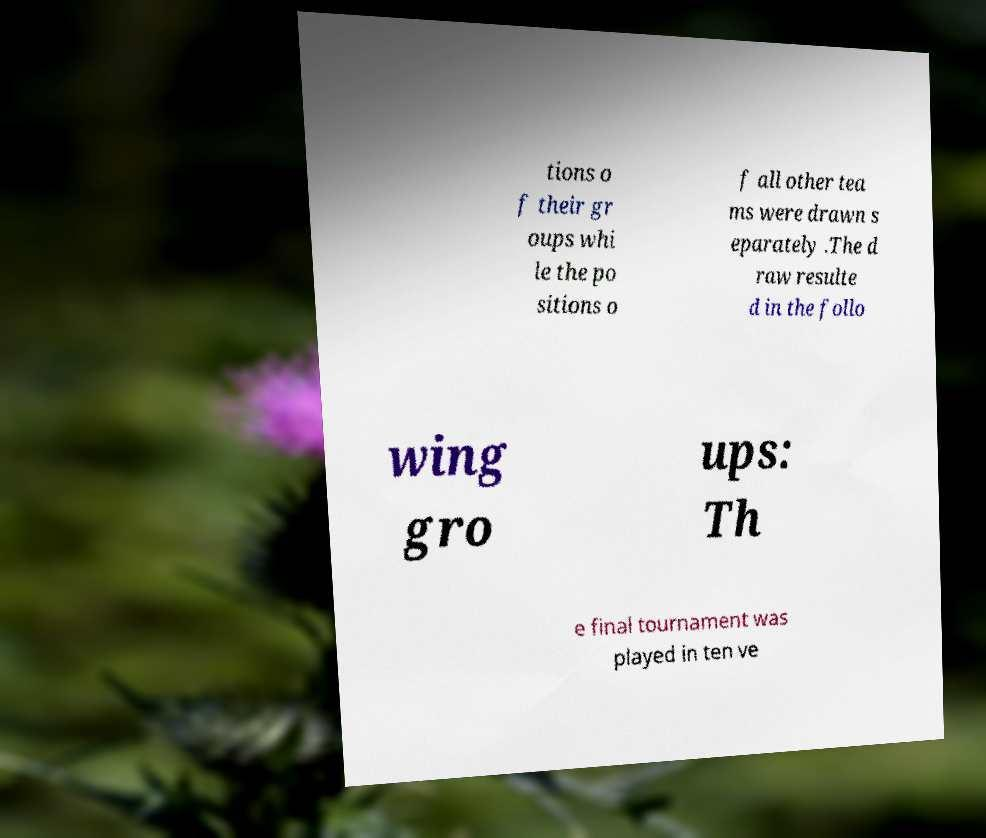For documentation purposes, I need the text within this image transcribed. Could you provide that? tions o f their gr oups whi le the po sitions o f all other tea ms were drawn s eparately .The d raw resulte d in the follo wing gro ups: Th e final tournament was played in ten ve 